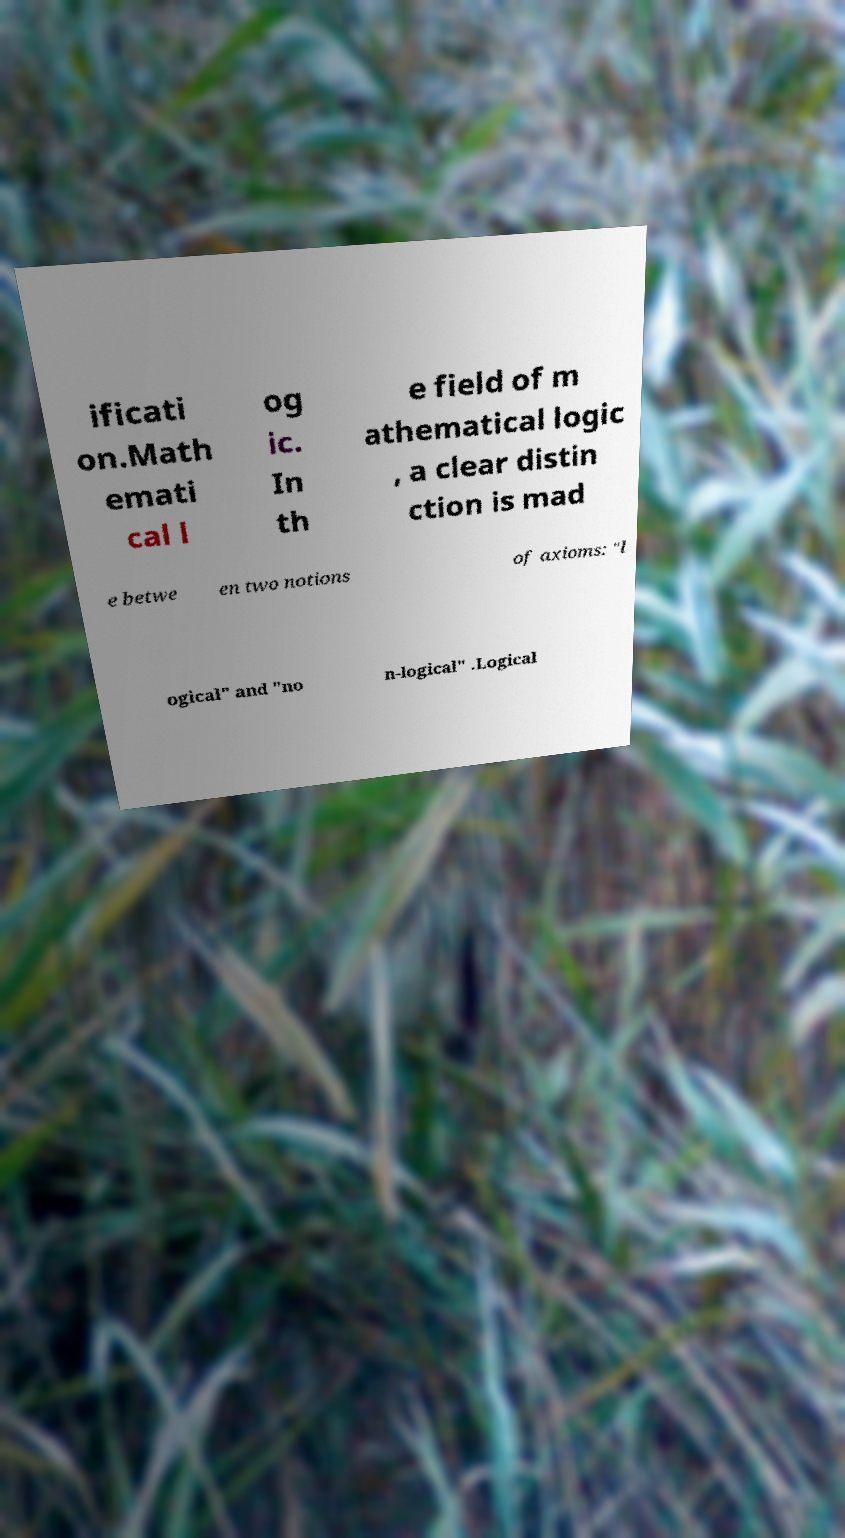I need the written content from this picture converted into text. Can you do that? ificati on.Math emati cal l og ic. In th e field of m athematical logic , a clear distin ction is mad e betwe en two notions of axioms: "l ogical" and "no n-logical" .Logical 